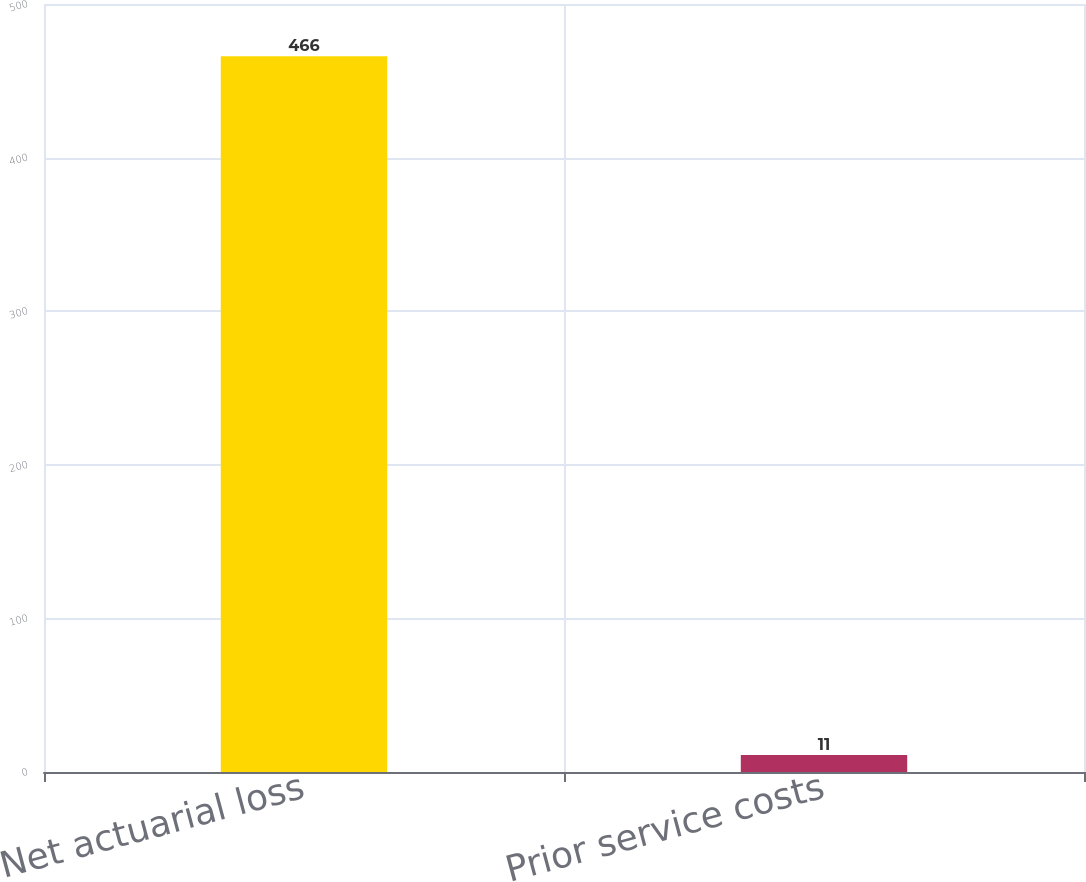Convert chart. <chart><loc_0><loc_0><loc_500><loc_500><bar_chart><fcel>Net actuarial loss<fcel>Prior service costs<nl><fcel>466<fcel>11<nl></chart> 